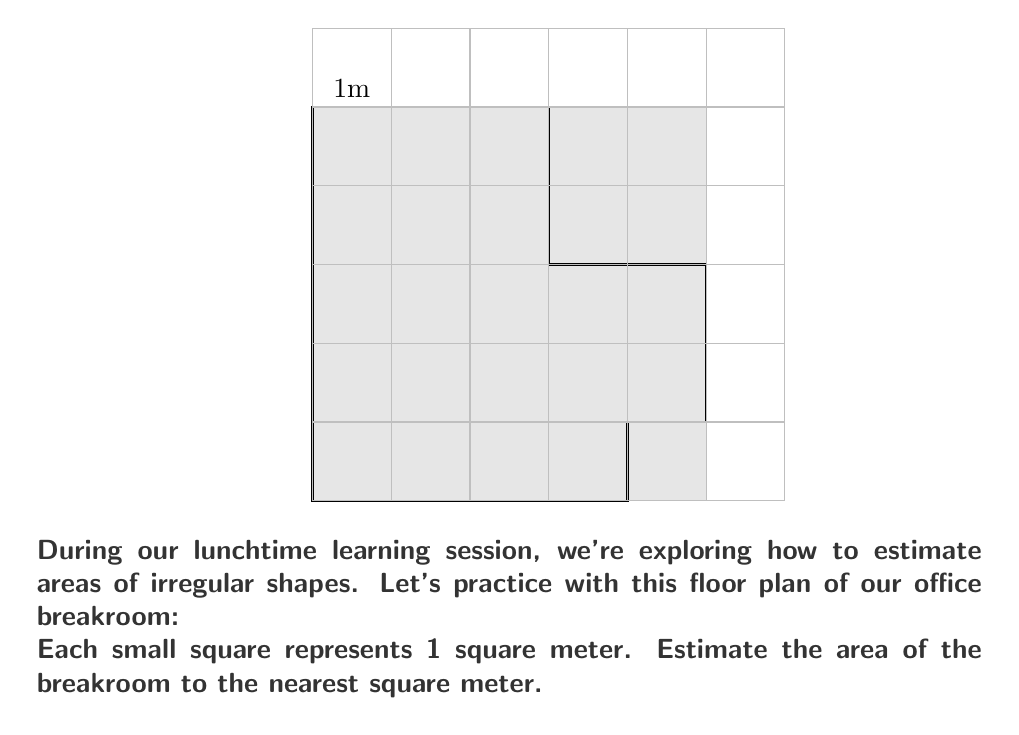Help me with this question. To estimate the area of this irregular shape using a grid overlay, we'll follow these steps:

1) Count the number of whole squares within the shape:
   There are 15 whole squares.

2) Count the number of partial squares:
   There are 8 partial squares.

3) Estimate how many of these partial squares would make a whole square:
   - 2 squares are about 3/4 full
   - 4 squares are about 1/2 full
   - 2 squares are about 1/4 full
   
   Estimation: $(2 \times 0.75) + (4 \times 0.5) + (2 \times 0.25) = 1.5 + 2 + 0.5 = 4$

4) Add the whole squares and the estimated partial squares:
   $15 + 4 = 19$

Therefore, the estimated area is 19 square meters.

To verify, we can calculate the exact area:
$A = (4 \times 5) + (1 \times 2) - (2 \times 2) = 20 - 4 = 16$ square meters

Our estimate of 19 square meters is reasonably close to the actual area of 16 square meters, considering the limitations of the grid method.
Answer: 19 $\text{m}^2$ 